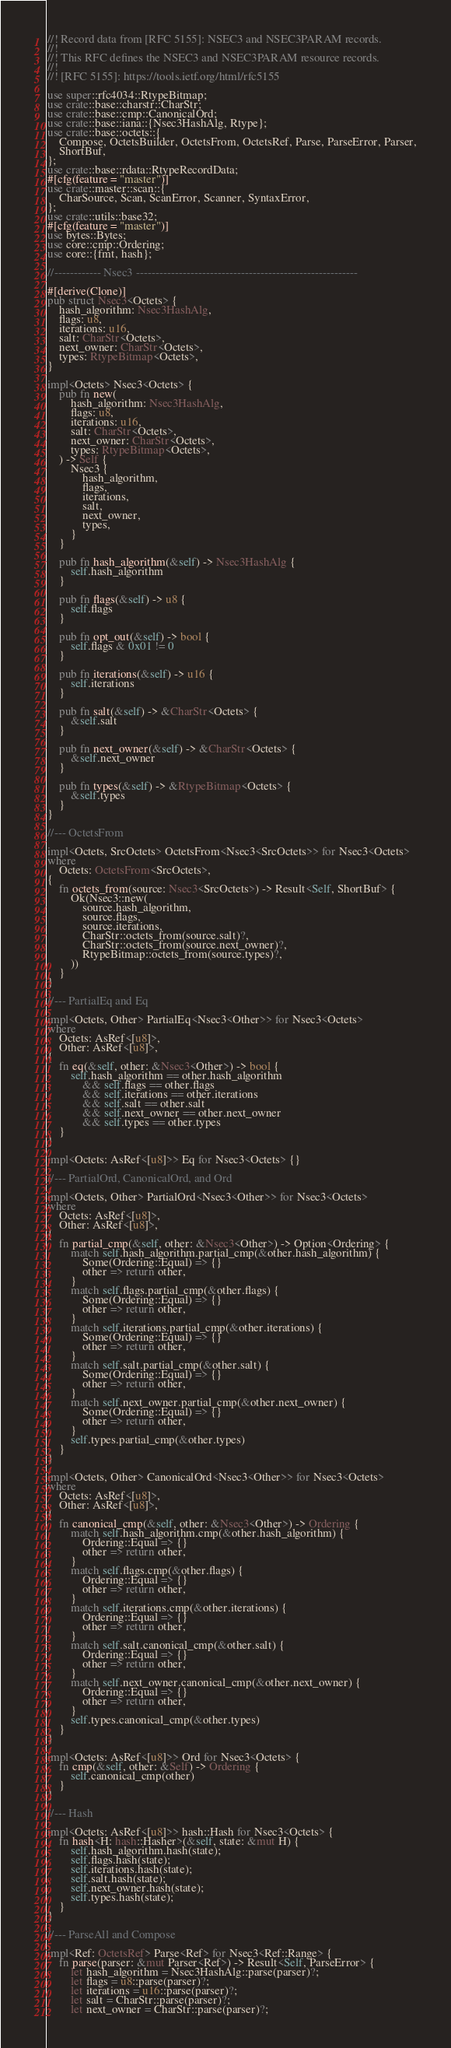<code> <loc_0><loc_0><loc_500><loc_500><_Rust_>//! Record data from [RFC 5155]: NSEC3 and NSEC3PARAM records.
//!
//! This RFC defines the NSEC3 and NSEC3PARAM resource records.
//!
//! [RFC 5155]: https://tools.ietf.org/html/rfc5155

use super::rfc4034::RtypeBitmap;
use crate::base::charstr::CharStr;
use crate::base::cmp::CanonicalOrd;
use crate::base::iana::{Nsec3HashAlg, Rtype};
use crate::base::octets::{
    Compose, OctetsBuilder, OctetsFrom, OctetsRef, Parse, ParseError, Parser,
    ShortBuf,
};
use crate::base::rdata::RtypeRecordData;
#[cfg(feature = "master")]
use crate::master::scan::{
    CharSource, Scan, ScanError, Scanner, SyntaxError,
};
use crate::utils::base32;
#[cfg(feature = "master")]
use bytes::Bytes;
use core::cmp::Ordering;
use core::{fmt, hash};

//------------ Nsec3 ---------------------------------------------------------

#[derive(Clone)]
pub struct Nsec3<Octets> {
    hash_algorithm: Nsec3HashAlg,
    flags: u8,
    iterations: u16,
    salt: CharStr<Octets>,
    next_owner: CharStr<Octets>,
    types: RtypeBitmap<Octets>,
}

impl<Octets> Nsec3<Octets> {
    pub fn new(
        hash_algorithm: Nsec3HashAlg,
        flags: u8,
        iterations: u16,
        salt: CharStr<Octets>,
        next_owner: CharStr<Octets>,
        types: RtypeBitmap<Octets>,
    ) -> Self {
        Nsec3 {
            hash_algorithm,
            flags,
            iterations,
            salt,
            next_owner,
            types,
        }
    }

    pub fn hash_algorithm(&self) -> Nsec3HashAlg {
        self.hash_algorithm
    }

    pub fn flags(&self) -> u8 {
        self.flags
    }

    pub fn opt_out(&self) -> bool {
        self.flags & 0x01 != 0
    }

    pub fn iterations(&self) -> u16 {
        self.iterations
    }

    pub fn salt(&self) -> &CharStr<Octets> {
        &self.salt
    }

    pub fn next_owner(&self) -> &CharStr<Octets> {
        &self.next_owner
    }

    pub fn types(&self) -> &RtypeBitmap<Octets> {
        &self.types
    }
}

//--- OctetsFrom

impl<Octets, SrcOctets> OctetsFrom<Nsec3<SrcOctets>> for Nsec3<Octets>
where
    Octets: OctetsFrom<SrcOctets>,
{
    fn octets_from(source: Nsec3<SrcOctets>) -> Result<Self, ShortBuf> {
        Ok(Nsec3::new(
            source.hash_algorithm,
            source.flags,
            source.iterations,
            CharStr::octets_from(source.salt)?,
            CharStr::octets_from(source.next_owner)?,
            RtypeBitmap::octets_from(source.types)?,
        ))
    }
}

//--- PartialEq and Eq

impl<Octets, Other> PartialEq<Nsec3<Other>> for Nsec3<Octets>
where
    Octets: AsRef<[u8]>,
    Other: AsRef<[u8]>,
{
    fn eq(&self, other: &Nsec3<Other>) -> bool {
        self.hash_algorithm == other.hash_algorithm
            && self.flags == other.flags
            && self.iterations == other.iterations
            && self.salt == other.salt
            && self.next_owner == other.next_owner
            && self.types == other.types
    }
}

impl<Octets: AsRef<[u8]>> Eq for Nsec3<Octets> {}

//--- PartialOrd, CanonicalOrd, and Ord

impl<Octets, Other> PartialOrd<Nsec3<Other>> for Nsec3<Octets>
where
    Octets: AsRef<[u8]>,
    Other: AsRef<[u8]>,
{
    fn partial_cmp(&self, other: &Nsec3<Other>) -> Option<Ordering> {
        match self.hash_algorithm.partial_cmp(&other.hash_algorithm) {
            Some(Ordering::Equal) => {}
            other => return other,
        }
        match self.flags.partial_cmp(&other.flags) {
            Some(Ordering::Equal) => {}
            other => return other,
        }
        match self.iterations.partial_cmp(&other.iterations) {
            Some(Ordering::Equal) => {}
            other => return other,
        }
        match self.salt.partial_cmp(&other.salt) {
            Some(Ordering::Equal) => {}
            other => return other,
        }
        match self.next_owner.partial_cmp(&other.next_owner) {
            Some(Ordering::Equal) => {}
            other => return other,
        }
        self.types.partial_cmp(&other.types)
    }
}

impl<Octets, Other> CanonicalOrd<Nsec3<Other>> for Nsec3<Octets>
where
    Octets: AsRef<[u8]>,
    Other: AsRef<[u8]>,
{
    fn canonical_cmp(&self, other: &Nsec3<Other>) -> Ordering {
        match self.hash_algorithm.cmp(&other.hash_algorithm) {
            Ordering::Equal => {}
            other => return other,
        }
        match self.flags.cmp(&other.flags) {
            Ordering::Equal => {}
            other => return other,
        }
        match self.iterations.cmp(&other.iterations) {
            Ordering::Equal => {}
            other => return other,
        }
        match self.salt.canonical_cmp(&other.salt) {
            Ordering::Equal => {}
            other => return other,
        }
        match self.next_owner.canonical_cmp(&other.next_owner) {
            Ordering::Equal => {}
            other => return other,
        }
        self.types.canonical_cmp(&other.types)
    }
}

impl<Octets: AsRef<[u8]>> Ord for Nsec3<Octets> {
    fn cmp(&self, other: &Self) -> Ordering {
        self.canonical_cmp(other)
    }
}

//--- Hash

impl<Octets: AsRef<[u8]>> hash::Hash for Nsec3<Octets> {
    fn hash<H: hash::Hasher>(&self, state: &mut H) {
        self.hash_algorithm.hash(state);
        self.flags.hash(state);
        self.iterations.hash(state);
        self.salt.hash(state);
        self.next_owner.hash(state);
        self.types.hash(state);
    }
}

//--- ParseAll and Compose

impl<Ref: OctetsRef> Parse<Ref> for Nsec3<Ref::Range> {
    fn parse(parser: &mut Parser<Ref>) -> Result<Self, ParseError> {
        let hash_algorithm = Nsec3HashAlg::parse(parser)?;
        let flags = u8::parse(parser)?;
        let iterations = u16::parse(parser)?;
        let salt = CharStr::parse(parser)?;
        let next_owner = CharStr::parse(parser)?;</code> 